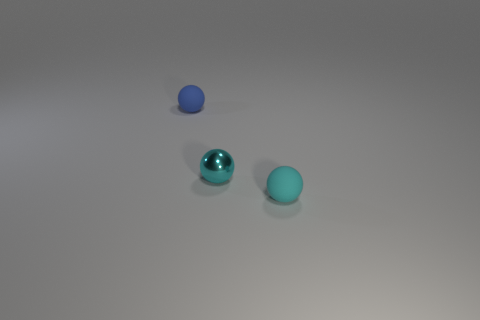Are there more small cyan objects left of the tiny blue rubber ball than red metal objects?
Keep it short and to the point. No. What is the small blue thing made of?
Keep it short and to the point. Rubber. There is a cyan thing that is made of the same material as the tiny blue thing; what is its shape?
Offer a terse response. Sphere. There is a cyan thing that is behind the rubber ball that is to the right of the cyan metal thing; what is its size?
Offer a terse response. Small. The matte ball on the right side of the blue matte object is what color?
Make the answer very short. Cyan. Is there a small cyan rubber thing of the same shape as the blue matte object?
Your response must be concise. Yes. Is the number of tiny cyan metallic objects that are right of the tiny shiny ball less than the number of blue things in front of the tiny blue object?
Provide a succinct answer. No. The small metallic ball has what color?
Offer a very short reply. Cyan. Is there a tiny thing that is behind the tiny matte object in front of the blue matte sphere?
Give a very brief answer. Yes. How many cyan objects are the same size as the blue sphere?
Keep it short and to the point. 2. 